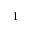<formula> <loc_0><loc_0><loc_500><loc_500>^ { - 1 }</formula> 